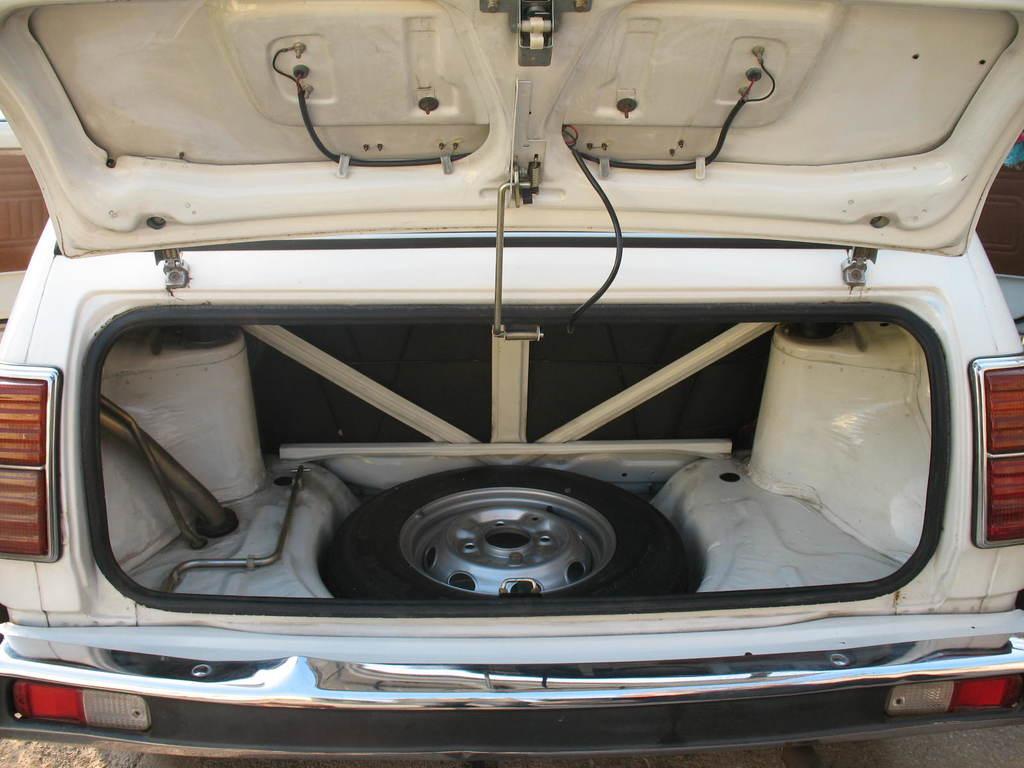Could you give a brief overview of what you see in this image? We can see white vehicle and we can see tire and rod in a vehicle. 